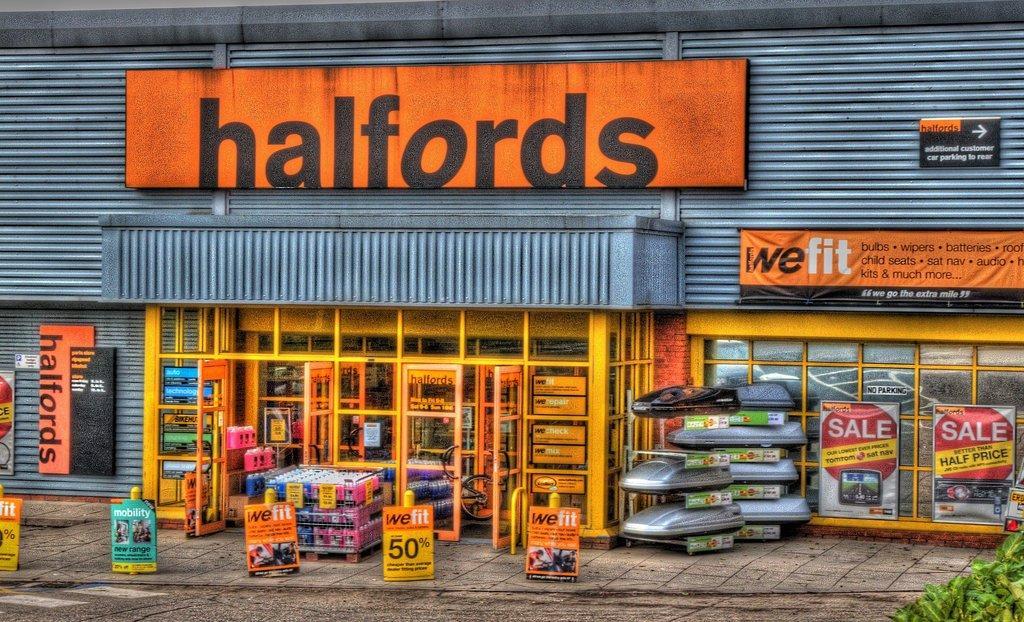In one or two sentences, can you explain what this image depicts? In this image, we can see a shed and there are some boards and banners and there is a store and we can see some other objects and there are poles and plants, there are glass doors. At the bottom, there is road. 